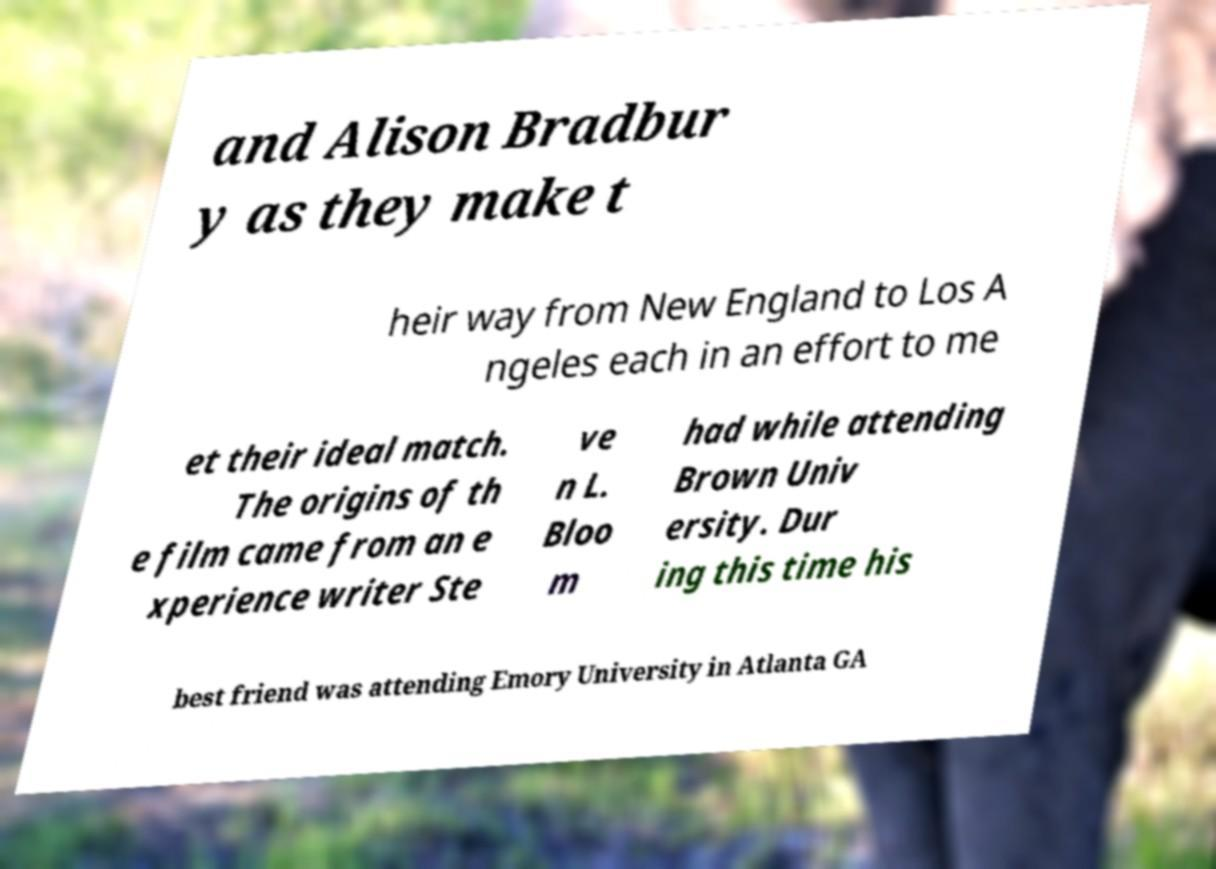I need the written content from this picture converted into text. Can you do that? and Alison Bradbur y as they make t heir way from New England to Los A ngeles each in an effort to me et their ideal match. The origins of th e film came from an e xperience writer Ste ve n L. Bloo m had while attending Brown Univ ersity. Dur ing this time his best friend was attending Emory University in Atlanta GA 